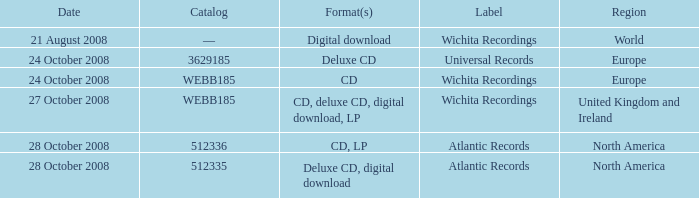What are the formats associated with the Atlantic Records label, catalog number 512336? CD, LP. Parse the table in full. {'header': ['Date', 'Catalog', 'Format(s)', 'Label', 'Region'], 'rows': [['21 August 2008', '—', 'Digital download', 'Wichita Recordings', 'World'], ['24 October 2008', '3629185', 'Deluxe CD', 'Universal Records', 'Europe'], ['24 October 2008', 'WEBB185', 'CD', 'Wichita Recordings', 'Europe'], ['27 October 2008', 'WEBB185', 'CD, deluxe CD, digital download, LP', 'Wichita Recordings', 'United Kingdom and Ireland'], ['28 October 2008', '512336', 'CD, LP', 'Atlantic Records', 'North America'], ['28 October 2008', '512335', 'Deluxe CD, digital download', 'Atlantic Records', 'North America']]} 